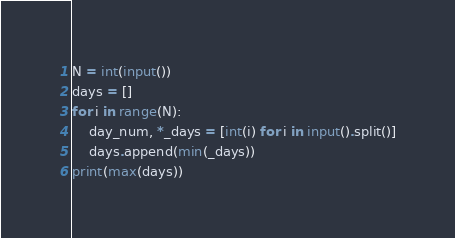<code> <loc_0><loc_0><loc_500><loc_500><_Python_>N = int(input())
days = []
for i in range(N):
    day_num, *_days = [int(i) for i in input().split()]
    days.append(min(_days))
print(max(days))
</code> 